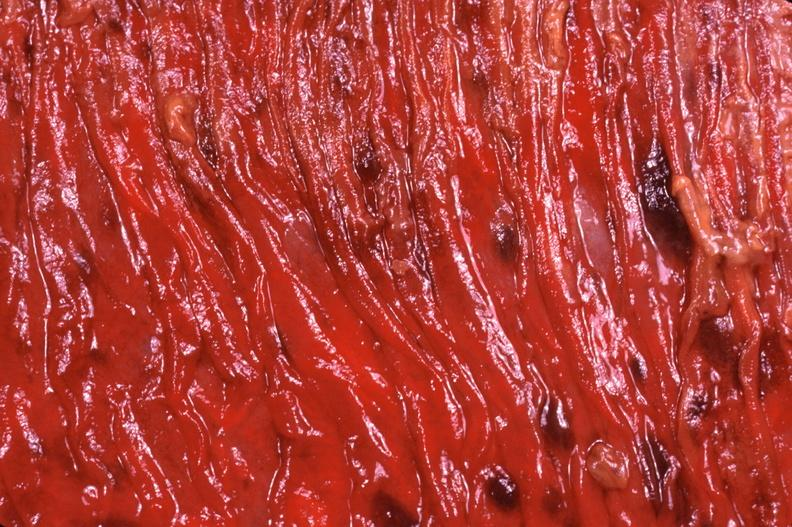where does this belong to?
Answer the question using a single word or phrase. Gastrointestinal system 